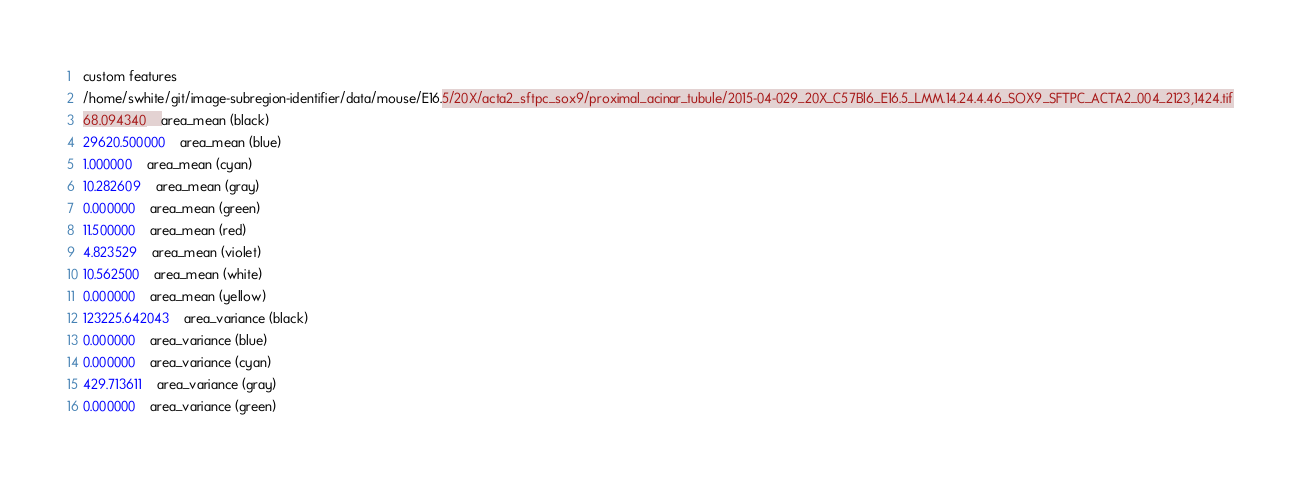Convert code to text. <code><loc_0><loc_0><loc_500><loc_500><_SML_>custom features
/home/swhite/git/image-subregion-identifier/data/mouse/E16.5/20X/acta2_sftpc_sox9/proximal_acinar_tubule/2015-04-029_20X_C57Bl6_E16.5_LMM.14.24.4.46_SOX9_SFTPC_ACTA2_004_2123,1424.tif
68.094340	area_mean (black)
29620.500000	area_mean (blue)
1.000000	area_mean (cyan)
10.282609	area_mean (gray)
0.000000	area_mean (green)
11.500000	area_mean (red)
4.823529	area_mean (violet)
10.562500	area_mean (white)
0.000000	area_mean (yellow)
123225.642043	area_variance (black)
0.000000	area_variance (blue)
0.000000	area_variance (cyan)
429.713611	area_variance (gray)
0.000000	area_variance (green)</code> 